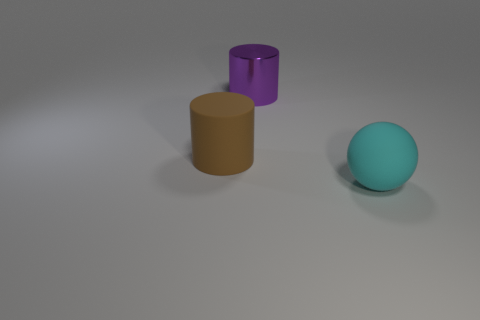Are there any other things that are made of the same material as the big purple object?
Give a very brief answer. No. How many large objects are either metal spheres or brown cylinders?
Offer a very short reply. 1. Is the number of large cyan matte balls in front of the cyan thing greater than the number of cyan objects in front of the purple cylinder?
Your answer should be very brief. No. What number of other things are there of the same size as the cyan ball?
Keep it short and to the point. 2. Do the big cylinder that is behind the large matte cylinder and the large cyan thing have the same material?
Give a very brief answer. No. How many other objects are the same color as the sphere?
Ensure brevity in your answer.  0. How many other objects are there of the same shape as the big cyan thing?
Make the answer very short. 0. There is a large thing that is in front of the large brown rubber object; is its shape the same as the rubber object that is left of the cyan rubber object?
Your answer should be compact. No. Is the number of big cyan rubber objects that are on the left side of the brown matte object the same as the number of brown matte cylinders that are in front of the large cyan sphere?
Provide a short and direct response. Yes. What is the shape of the rubber thing left of the big thing behind the large rubber thing behind the big cyan ball?
Ensure brevity in your answer.  Cylinder. 